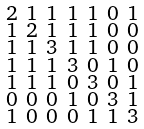Convert formula to latex. <formula><loc_0><loc_0><loc_500><loc_500>\begin{smallmatrix} 2 & 1 & 1 & 1 & 1 & 0 & 1 \\ 1 & 2 & 1 & 1 & 1 & 0 & 0 \\ 1 & 1 & 3 & 1 & 1 & 0 & 0 \\ 1 & 1 & 1 & 3 & 0 & 1 & 0 \\ 1 & 1 & 1 & 0 & 3 & 0 & 1 \\ 0 & 0 & 0 & 1 & 0 & 3 & 1 \\ 1 & 0 & 0 & 0 & 1 & 1 & 3 \end{smallmatrix}</formula> 